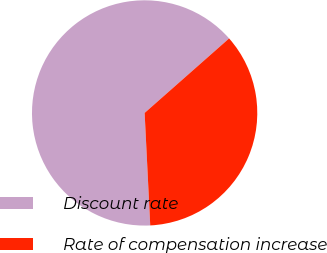Convert chart. <chart><loc_0><loc_0><loc_500><loc_500><pie_chart><fcel>Discount rate<fcel>Rate of compensation increase<nl><fcel>64.29%<fcel>35.71%<nl></chart> 